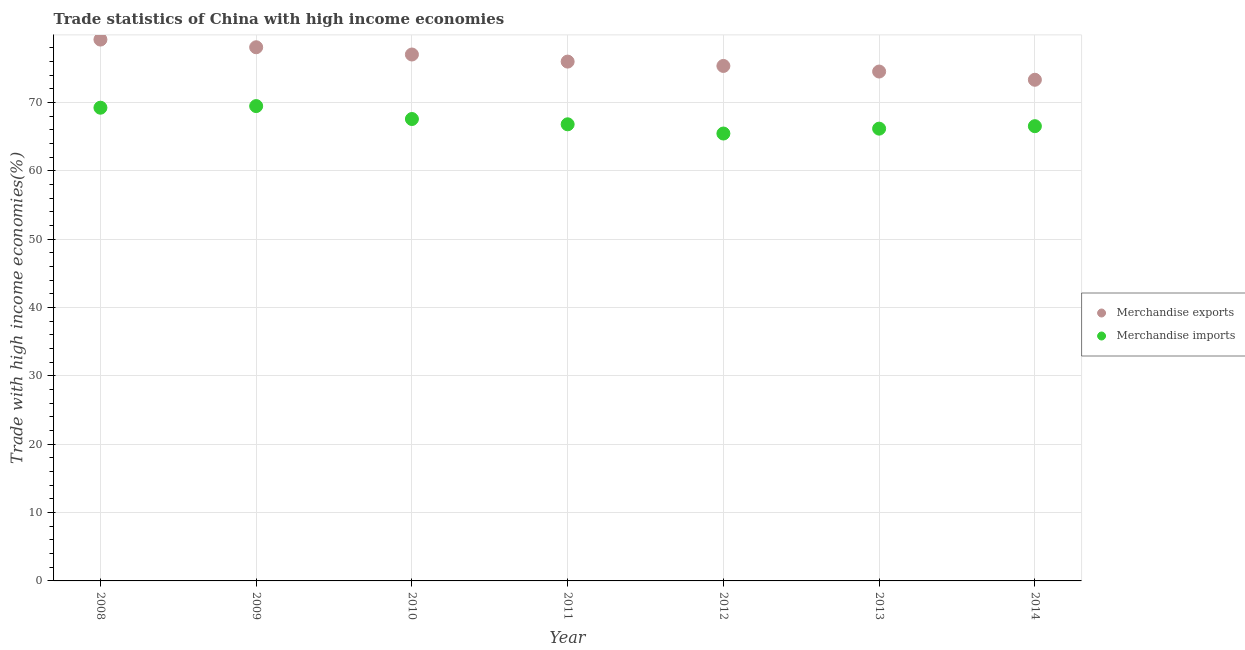How many different coloured dotlines are there?
Offer a terse response. 2. What is the merchandise imports in 2010?
Offer a very short reply. 67.58. Across all years, what is the maximum merchandise imports?
Keep it short and to the point. 69.48. Across all years, what is the minimum merchandise exports?
Give a very brief answer. 73.33. What is the total merchandise imports in the graph?
Offer a very short reply. 471.28. What is the difference between the merchandise imports in 2009 and that in 2014?
Your answer should be very brief. 2.94. What is the difference between the merchandise exports in 2012 and the merchandise imports in 2013?
Your response must be concise. 9.17. What is the average merchandise imports per year?
Your answer should be very brief. 67.33. In the year 2013, what is the difference between the merchandise exports and merchandise imports?
Your answer should be compact. 8.36. In how many years, is the merchandise imports greater than 60 %?
Your response must be concise. 7. What is the ratio of the merchandise imports in 2009 to that in 2011?
Keep it short and to the point. 1.04. What is the difference between the highest and the second highest merchandise imports?
Offer a very short reply. 0.24. What is the difference between the highest and the lowest merchandise imports?
Your answer should be very brief. 4.02. In how many years, is the merchandise imports greater than the average merchandise imports taken over all years?
Make the answer very short. 3. Does the merchandise imports monotonically increase over the years?
Ensure brevity in your answer.  No. How many dotlines are there?
Ensure brevity in your answer.  2. How many years are there in the graph?
Offer a terse response. 7. What is the difference between two consecutive major ticks on the Y-axis?
Keep it short and to the point. 10. Are the values on the major ticks of Y-axis written in scientific E-notation?
Your answer should be very brief. No. What is the title of the graph?
Your answer should be very brief. Trade statistics of China with high income economies. Does "Time to export" appear as one of the legend labels in the graph?
Ensure brevity in your answer.  No. What is the label or title of the Y-axis?
Your answer should be compact. Trade with high income economies(%). What is the Trade with high income economies(%) of Merchandise exports in 2008?
Ensure brevity in your answer.  79.21. What is the Trade with high income economies(%) of Merchandise imports in 2008?
Keep it short and to the point. 69.24. What is the Trade with high income economies(%) in Merchandise exports in 2009?
Ensure brevity in your answer.  78.08. What is the Trade with high income economies(%) in Merchandise imports in 2009?
Give a very brief answer. 69.48. What is the Trade with high income economies(%) in Merchandise exports in 2010?
Your answer should be compact. 77.02. What is the Trade with high income economies(%) in Merchandise imports in 2010?
Make the answer very short. 67.58. What is the Trade with high income economies(%) of Merchandise exports in 2011?
Your answer should be very brief. 75.99. What is the Trade with high income economies(%) of Merchandise imports in 2011?
Keep it short and to the point. 66.81. What is the Trade with high income economies(%) in Merchandise exports in 2012?
Provide a short and direct response. 75.35. What is the Trade with high income economies(%) in Merchandise imports in 2012?
Provide a succinct answer. 65.46. What is the Trade with high income economies(%) in Merchandise exports in 2013?
Your response must be concise. 74.53. What is the Trade with high income economies(%) of Merchandise imports in 2013?
Ensure brevity in your answer.  66.18. What is the Trade with high income economies(%) in Merchandise exports in 2014?
Provide a short and direct response. 73.33. What is the Trade with high income economies(%) of Merchandise imports in 2014?
Your response must be concise. 66.54. Across all years, what is the maximum Trade with high income economies(%) of Merchandise exports?
Make the answer very short. 79.21. Across all years, what is the maximum Trade with high income economies(%) of Merchandise imports?
Your answer should be very brief. 69.48. Across all years, what is the minimum Trade with high income economies(%) of Merchandise exports?
Offer a terse response. 73.33. Across all years, what is the minimum Trade with high income economies(%) in Merchandise imports?
Give a very brief answer. 65.46. What is the total Trade with high income economies(%) in Merchandise exports in the graph?
Make the answer very short. 533.51. What is the total Trade with high income economies(%) of Merchandise imports in the graph?
Make the answer very short. 471.28. What is the difference between the Trade with high income economies(%) of Merchandise exports in 2008 and that in 2009?
Offer a terse response. 1.12. What is the difference between the Trade with high income economies(%) in Merchandise imports in 2008 and that in 2009?
Your answer should be very brief. -0.24. What is the difference between the Trade with high income economies(%) of Merchandise exports in 2008 and that in 2010?
Provide a succinct answer. 2.19. What is the difference between the Trade with high income economies(%) of Merchandise imports in 2008 and that in 2010?
Your answer should be compact. 1.65. What is the difference between the Trade with high income economies(%) in Merchandise exports in 2008 and that in 2011?
Provide a short and direct response. 3.22. What is the difference between the Trade with high income economies(%) of Merchandise imports in 2008 and that in 2011?
Ensure brevity in your answer.  2.43. What is the difference between the Trade with high income economies(%) of Merchandise exports in 2008 and that in 2012?
Keep it short and to the point. 3.86. What is the difference between the Trade with high income economies(%) in Merchandise imports in 2008 and that in 2012?
Make the answer very short. 3.78. What is the difference between the Trade with high income economies(%) of Merchandise exports in 2008 and that in 2013?
Give a very brief answer. 4.68. What is the difference between the Trade with high income economies(%) of Merchandise imports in 2008 and that in 2013?
Offer a very short reply. 3.06. What is the difference between the Trade with high income economies(%) in Merchandise exports in 2008 and that in 2014?
Your response must be concise. 5.88. What is the difference between the Trade with high income economies(%) of Merchandise imports in 2008 and that in 2014?
Make the answer very short. 2.7. What is the difference between the Trade with high income economies(%) in Merchandise exports in 2009 and that in 2010?
Provide a succinct answer. 1.06. What is the difference between the Trade with high income economies(%) of Merchandise imports in 2009 and that in 2010?
Make the answer very short. 1.89. What is the difference between the Trade with high income economies(%) in Merchandise exports in 2009 and that in 2011?
Provide a short and direct response. 2.1. What is the difference between the Trade with high income economies(%) of Merchandise imports in 2009 and that in 2011?
Your answer should be very brief. 2.67. What is the difference between the Trade with high income economies(%) in Merchandise exports in 2009 and that in 2012?
Ensure brevity in your answer.  2.73. What is the difference between the Trade with high income economies(%) of Merchandise imports in 2009 and that in 2012?
Give a very brief answer. 4.02. What is the difference between the Trade with high income economies(%) of Merchandise exports in 2009 and that in 2013?
Offer a terse response. 3.55. What is the difference between the Trade with high income economies(%) in Merchandise imports in 2009 and that in 2013?
Ensure brevity in your answer.  3.3. What is the difference between the Trade with high income economies(%) of Merchandise exports in 2009 and that in 2014?
Make the answer very short. 4.76. What is the difference between the Trade with high income economies(%) in Merchandise imports in 2009 and that in 2014?
Provide a short and direct response. 2.94. What is the difference between the Trade with high income economies(%) in Merchandise exports in 2010 and that in 2011?
Provide a short and direct response. 1.04. What is the difference between the Trade with high income economies(%) of Merchandise imports in 2010 and that in 2011?
Offer a terse response. 0.78. What is the difference between the Trade with high income economies(%) in Merchandise exports in 2010 and that in 2012?
Offer a terse response. 1.67. What is the difference between the Trade with high income economies(%) in Merchandise imports in 2010 and that in 2012?
Ensure brevity in your answer.  2.12. What is the difference between the Trade with high income economies(%) in Merchandise exports in 2010 and that in 2013?
Make the answer very short. 2.49. What is the difference between the Trade with high income economies(%) in Merchandise imports in 2010 and that in 2013?
Ensure brevity in your answer.  1.41. What is the difference between the Trade with high income economies(%) in Merchandise exports in 2010 and that in 2014?
Offer a very short reply. 3.7. What is the difference between the Trade with high income economies(%) of Merchandise imports in 2010 and that in 2014?
Your answer should be compact. 1.05. What is the difference between the Trade with high income economies(%) of Merchandise exports in 2011 and that in 2012?
Offer a terse response. 0.64. What is the difference between the Trade with high income economies(%) in Merchandise imports in 2011 and that in 2012?
Your answer should be compact. 1.35. What is the difference between the Trade with high income economies(%) of Merchandise exports in 2011 and that in 2013?
Offer a very short reply. 1.45. What is the difference between the Trade with high income economies(%) in Merchandise imports in 2011 and that in 2013?
Offer a very short reply. 0.63. What is the difference between the Trade with high income economies(%) of Merchandise exports in 2011 and that in 2014?
Keep it short and to the point. 2.66. What is the difference between the Trade with high income economies(%) in Merchandise imports in 2011 and that in 2014?
Make the answer very short. 0.27. What is the difference between the Trade with high income economies(%) in Merchandise exports in 2012 and that in 2013?
Offer a very short reply. 0.82. What is the difference between the Trade with high income economies(%) of Merchandise imports in 2012 and that in 2013?
Your answer should be very brief. -0.71. What is the difference between the Trade with high income economies(%) in Merchandise exports in 2012 and that in 2014?
Your answer should be compact. 2.02. What is the difference between the Trade with high income economies(%) of Merchandise imports in 2012 and that in 2014?
Provide a succinct answer. -1.08. What is the difference between the Trade with high income economies(%) of Merchandise exports in 2013 and that in 2014?
Provide a succinct answer. 1.2. What is the difference between the Trade with high income economies(%) in Merchandise imports in 2013 and that in 2014?
Ensure brevity in your answer.  -0.36. What is the difference between the Trade with high income economies(%) in Merchandise exports in 2008 and the Trade with high income economies(%) in Merchandise imports in 2009?
Offer a terse response. 9.73. What is the difference between the Trade with high income economies(%) in Merchandise exports in 2008 and the Trade with high income economies(%) in Merchandise imports in 2010?
Your answer should be compact. 11.62. What is the difference between the Trade with high income economies(%) in Merchandise exports in 2008 and the Trade with high income economies(%) in Merchandise imports in 2011?
Keep it short and to the point. 12.4. What is the difference between the Trade with high income economies(%) in Merchandise exports in 2008 and the Trade with high income economies(%) in Merchandise imports in 2012?
Your answer should be compact. 13.75. What is the difference between the Trade with high income economies(%) of Merchandise exports in 2008 and the Trade with high income economies(%) of Merchandise imports in 2013?
Your response must be concise. 13.03. What is the difference between the Trade with high income economies(%) of Merchandise exports in 2008 and the Trade with high income economies(%) of Merchandise imports in 2014?
Your response must be concise. 12.67. What is the difference between the Trade with high income economies(%) in Merchandise exports in 2009 and the Trade with high income economies(%) in Merchandise imports in 2010?
Provide a short and direct response. 10.5. What is the difference between the Trade with high income economies(%) in Merchandise exports in 2009 and the Trade with high income economies(%) in Merchandise imports in 2011?
Provide a short and direct response. 11.27. What is the difference between the Trade with high income economies(%) of Merchandise exports in 2009 and the Trade with high income economies(%) of Merchandise imports in 2012?
Offer a terse response. 12.62. What is the difference between the Trade with high income economies(%) in Merchandise exports in 2009 and the Trade with high income economies(%) in Merchandise imports in 2013?
Keep it short and to the point. 11.91. What is the difference between the Trade with high income economies(%) in Merchandise exports in 2009 and the Trade with high income economies(%) in Merchandise imports in 2014?
Keep it short and to the point. 11.55. What is the difference between the Trade with high income economies(%) in Merchandise exports in 2010 and the Trade with high income economies(%) in Merchandise imports in 2011?
Your answer should be compact. 10.21. What is the difference between the Trade with high income economies(%) of Merchandise exports in 2010 and the Trade with high income economies(%) of Merchandise imports in 2012?
Your response must be concise. 11.56. What is the difference between the Trade with high income economies(%) of Merchandise exports in 2010 and the Trade with high income economies(%) of Merchandise imports in 2013?
Make the answer very short. 10.85. What is the difference between the Trade with high income economies(%) in Merchandise exports in 2010 and the Trade with high income economies(%) in Merchandise imports in 2014?
Give a very brief answer. 10.49. What is the difference between the Trade with high income economies(%) of Merchandise exports in 2011 and the Trade with high income economies(%) of Merchandise imports in 2012?
Your response must be concise. 10.52. What is the difference between the Trade with high income economies(%) of Merchandise exports in 2011 and the Trade with high income economies(%) of Merchandise imports in 2013?
Your answer should be compact. 9.81. What is the difference between the Trade with high income economies(%) of Merchandise exports in 2011 and the Trade with high income economies(%) of Merchandise imports in 2014?
Make the answer very short. 9.45. What is the difference between the Trade with high income economies(%) of Merchandise exports in 2012 and the Trade with high income economies(%) of Merchandise imports in 2013?
Give a very brief answer. 9.17. What is the difference between the Trade with high income economies(%) in Merchandise exports in 2012 and the Trade with high income economies(%) in Merchandise imports in 2014?
Ensure brevity in your answer.  8.81. What is the difference between the Trade with high income economies(%) of Merchandise exports in 2013 and the Trade with high income economies(%) of Merchandise imports in 2014?
Keep it short and to the point. 7.99. What is the average Trade with high income economies(%) in Merchandise exports per year?
Offer a very short reply. 76.22. What is the average Trade with high income economies(%) of Merchandise imports per year?
Provide a succinct answer. 67.33. In the year 2008, what is the difference between the Trade with high income economies(%) of Merchandise exports and Trade with high income economies(%) of Merchandise imports?
Offer a terse response. 9.97. In the year 2009, what is the difference between the Trade with high income economies(%) of Merchandise exports and Trade with high income economies(%) of Merchandise imports?
Offer a very short reply. 8.61. In the year 2010, what is the difference between the Trade with high income economies(%) in Merchandise exports and Trade with high income economies(%) in Merchandise imports?
Offer a terse response. 9.44. In the year 2011, what is the difference between the Trade with high income economies(%) in Merchandise exports and Trade with high income economies(%) in Merchandise imports?
Your answer should be compact. 9.18. In the year 2012, what is the difference between the Trade with high income economies(%) in Merchandise exports and Trade with high income economies(%) in Merchandise imports?
Provide a short and direct response. 9.89. In the year 2013, what is the difference between the Trade with high income economies(%) in Merchandise exports and Trade with high income economies(%) in Merchandise imports?
Your answer should be very brief. 8.36. In the year 2014, what is the difference between the Trade with high income economies(%) in Merchandise exports and Trade with high income economies(%) in Merchandise imports?
Give a very brief answer. 6.79. What is the ratio of the Trade with high income economies(%) of Merchandise exports in 2008 to that in 2009?
Provide a short and direct response. 1.01. What is the ratio of the Trade with high income economies(%) in Merchandise imports in 2008 to that in 2009?
Keep it short and to the point. 1. What is the ratio of the Trade with high income economies(%) of Merchandise exports in 2008 to that in 2010?
Offer a terse response. 1.03. What is the ratio of the Trade with high income economies(%) in Merchandise imports in 2008 to that in 2010?
Provide a succinct answer. 1.02. What is the ratio of the Trade with high income economies(%) of Merchandise exports in 2008 to that in 2011?
Give a very brief answer. 1.04. What is the ratio of the Trade with high income economies(%) of Merchandise imports in 2008 to that in 2011?
Provide a succinct answer. 1.04. What is the ratio of the Trade with high income economies(%) of Merchandise exports in 2008 to that in 2012?
Offer a very short reply. 1.05. What is the ratio of the Trade with high income economies(%) in Merchandise imports in 2008 to that in 2012?
Provide a short and direct response. 1.06. What is the ratio of the Trade with high income economies(%) in Merchandise exports in 2008 to that in 2013?
Provide a short and direct response. 1.06. What is the ratio of the Trade with high income economies(%) in Merchandise imports in 2008 to that in 2013?
Offer a very short reply. 1.05. What is the ratio of the Trade with high income economies(%) of Merchandise exports in 2008 to that in 2014?
Give a very brief answer. 1.08. What is the ratio of the Trade with high income economies(%) of Merchandise imports in 2008 to that in 2014?
Offer a very short reply. 1.04. What is the ratio of the Trade with high income economies(%) in Merchandise exports in 2009 to that in 2010?
Provide a short and direct response. 1.01. What is the ratio of the Trade with high income economies(%) of Merchandise imports in 2009 to that in 2010?
Provide a succinct answer. 1.03. What is the ratio of the Trade with high income economies(%) in Merchandise exports in 2009 to that in 2011?
Your answer should be very brief. 1.03. What is the ratio of the Trade with high income economies(%) of Merchandise imports in 2009 to that in 2011?
Your answer should be very brief. 1.04. What is the ratio of the Trade with high income economies(%) in Merchandise exports in 2009 to that in 2012?
Provide a succinct answer. 1.04. What is the ratio of the Trade with high income economies(%) in Merchandise imports in 2009 to that in 2012?
Provide a succinct answer. 1.06. What is the ratio of the Trade with high income economies(%) in Merchandise exports in 2009 to that in 2013?
Offer a terse response. 1.05. What is the ratio of the Trade with high income economies(%) of Merchandise imports in 2009 to that in 2013?
Make the answer very short. 1.05. What is the ratio of the Trade with high income economies(%) in Merchandise exports in 2009 to that in 2014?
Provide a succinct answer. 1.06. What is the ratio of the Trade with high income economies(%) in Merchandise imports in 2009 to that in 2014?
Your answer should be compact. 1.04. What is the ratio of the Trade with high income economies(%) of Merchandise exports in 2010 to that in 2011?
Your response must be concise. 1.01. What is the ratio of the Trade with high income economies(%) of Merchandise imports in 2010 to that in 2011?
Give a very brief answer. 1.01. What is the ratio of the Trade with high income economies(%) of Merchandise exports in 2010 to that in 2012?
Make the answer very short. 1.02. What is the ratio of the Trade with high income economies(%) of Merchandise imports in 2010 to that in 2012?
Your answer should be very brief. 1.03. What is the ratio of the Trade with high income economies(%) in Merchandise exports in 2010 to that in 2013?
Your response must be concise. 1.03. What is the ratio of the Trade with high income economies(%) in Merchandise imports in 2010 to that in 2013?
Your response must be concise. 1.02. What is the ratio of the Trade with high income economies(%) in Merchandise exports in 2010 to that in 2014?
Offer a terse response. 1.05. What is the ratio of the Trade with high income economies(%) in Merchandise imports in 2010 to that in 2014?
Give a very brief answer. 1.02. What is the ratio of the Trade with high income economies(%) of Merchandise exports in 2011 to that in 2012?
Provide a short and direct response. 1.01. What is the ratio of the Trade with high income economies(%) in Merchandise imports in 2011 to that in 2012?
Ensure brevity in your answer.  1.02. What is the ratio of the Trade with high income economies(%) in Merchandise exports in 2011 to that in 2013?
Your answer should be very brief. 1.02. What is the ratio of the Trade with high income economies(%) of Merchandise imports in 2011 to that in 2013?
Ensure brevity in your answer.  1.01. What is the ratio of the Trade with high income economies(%) in Merchandise exports in 2011 to that in 2014?
Give a very brief answer. 1.04. What is the ratio of the Trade with high income economies(%) of Merchandise exports in 2012 to that in 2013?
Give a very brief answer. 1.01. What is the ratio of the Trade with high income economies(%) of Merchandise exports in 2012 to that in 2014?
Ensure brevity in your answer.  1.03. What is the ratio of the Trade with high income economies(%) of Merchandise imports in 2012 to that in 2014?
Your answer should be very brief. 0.98. What is the ratio of the Trade with high income economies(%) in Merchandise exports in 2013 to that in 2014?
Your answer should be very brief. 1.02. What is the ratio of the Trade with high income economies(%) in Merchandise imports in 2013 to that in 2014?
Provide a short and direct response. 0.99. What is the difference between the highest and the second highest Trade with high income economies(%) in Merchandise exports?
Offer a terse response. 1.12. What is the difference between the highest and the second highest Trade with high income economies(%) of Merchandise imports?
Offer a very short reply. 0.24. What is the difference between the highest and the lowest Trade with high income economies(%) of Merchandise exports?
Provide a succinct answer. 5.88. What is the difference between the highest and the lowest Trade with high income economies(%) in Merchandise imports?
Provide a short and direct response. 4.02. 